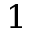<formula> <loc_0><loc_0><loc_500><loc_500>1</formula> 